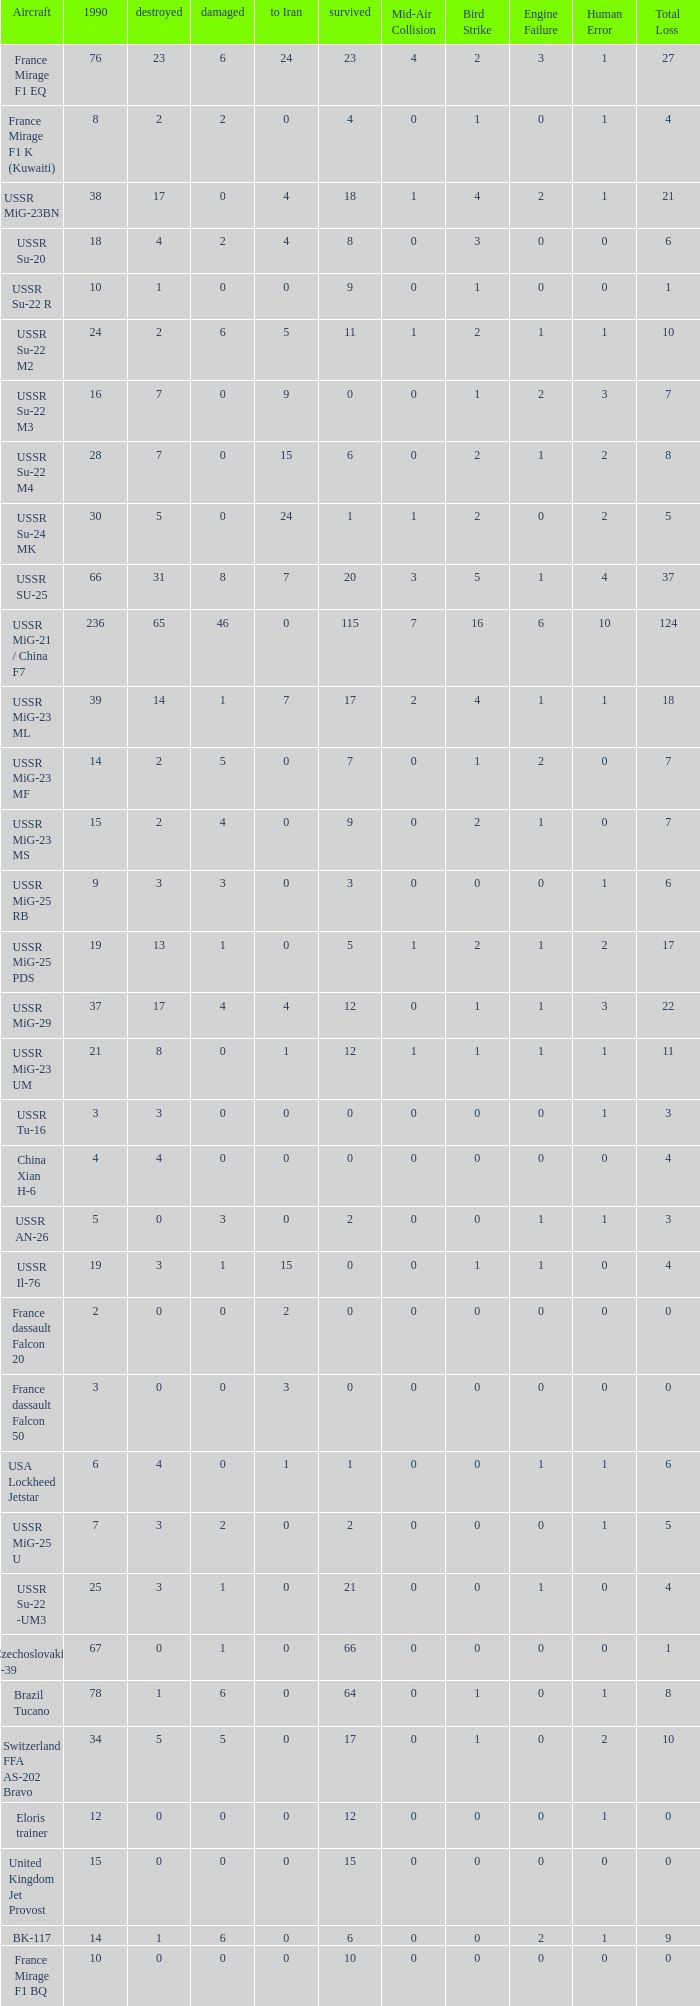If there were 14 in 1990 and 6 survived how many were destroyed? 1.0. 